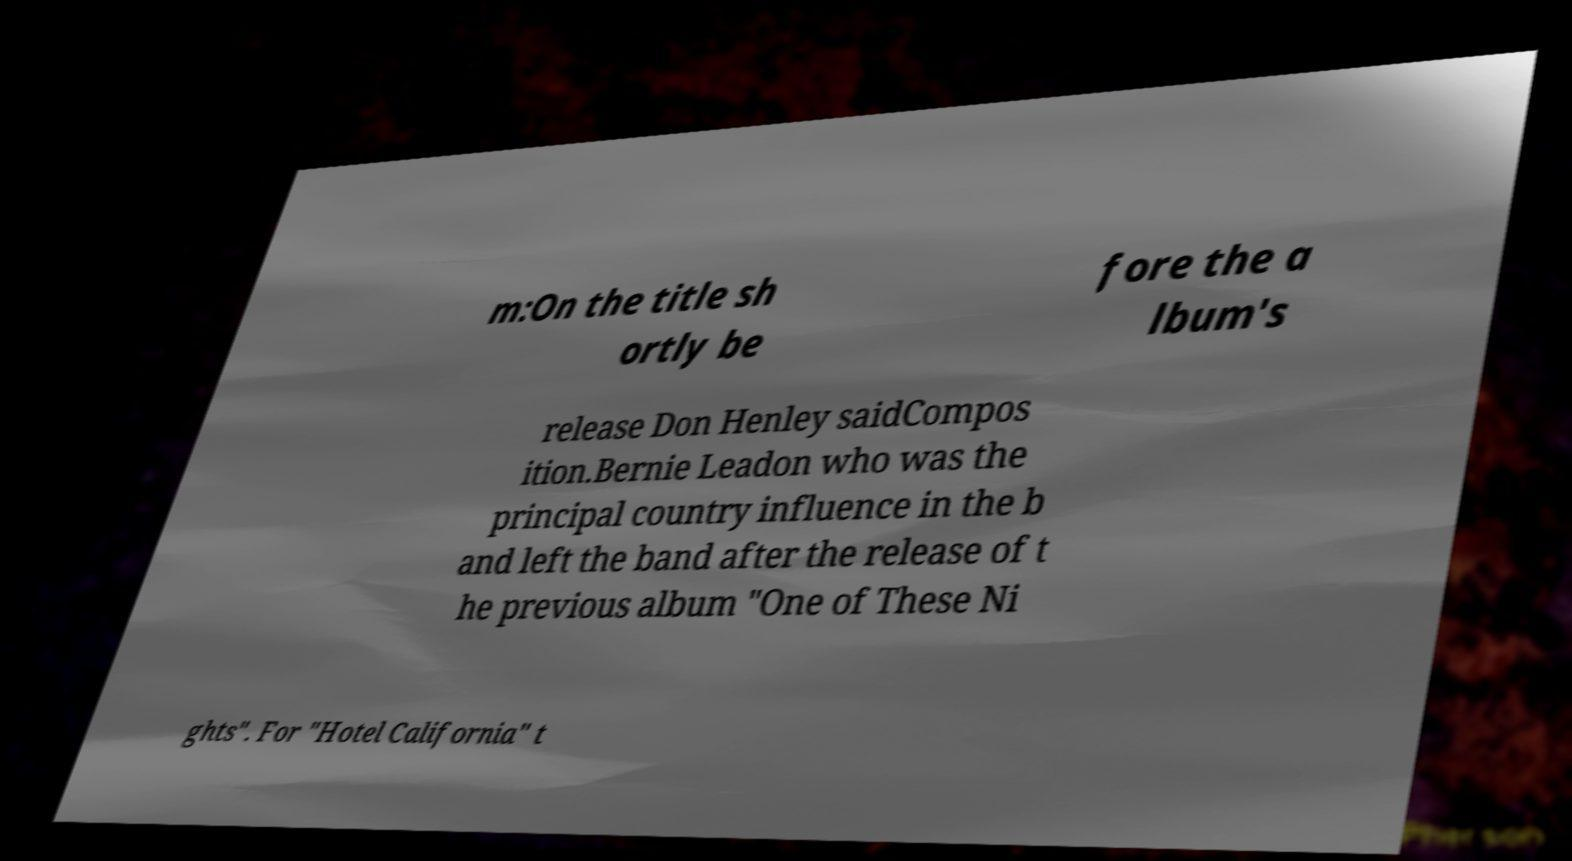I need the written content from this picture converted into text. Can you do that? m:On the title sh ortly be fore the a lbum's release Don Henley saidCompos ition.Bernie Leadon who was the principal country influence in the b and left the band after the release of t he previous album "One of These Ni ghts". For "Hotel California" t 